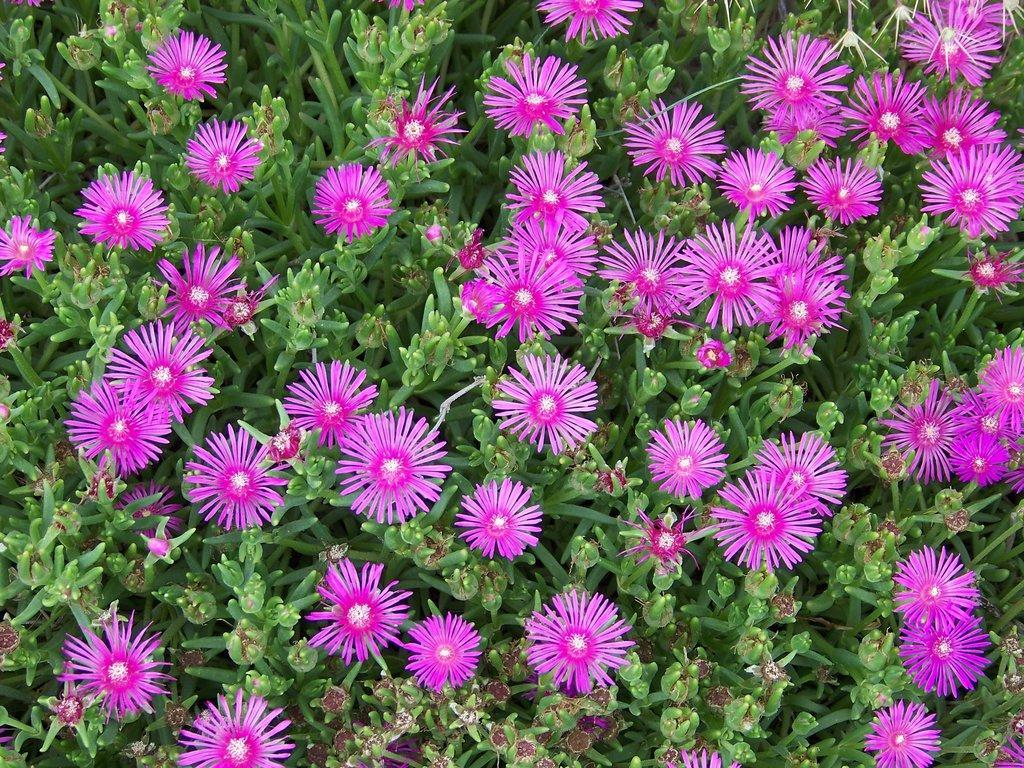Describe this image in one or two sentences. In this image there are plants and pink flowers were on it. 